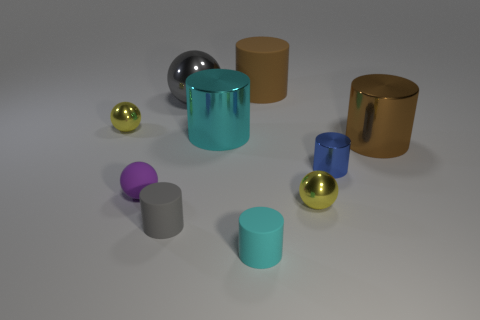Subtract all purple spheres. How many spheres are left? 3 Subtract all brown shiny cylinders. How many cylinders are left? 5 Subtract all green spheres. Subtract all green cylinders. How many spheres are left? 4 Subtract all spheres. How many objects are left? 6 Add 9 small gray rubber things. How many small gray rubber things exist? 10 Subtract 2 cyan cylinders. How many objects are left? 8 Subtract all spheres. Subtract all tiny gray things. How many objects are left? 5 Add 9 small gray cylinders. How many small gray cylinders are left? 10 